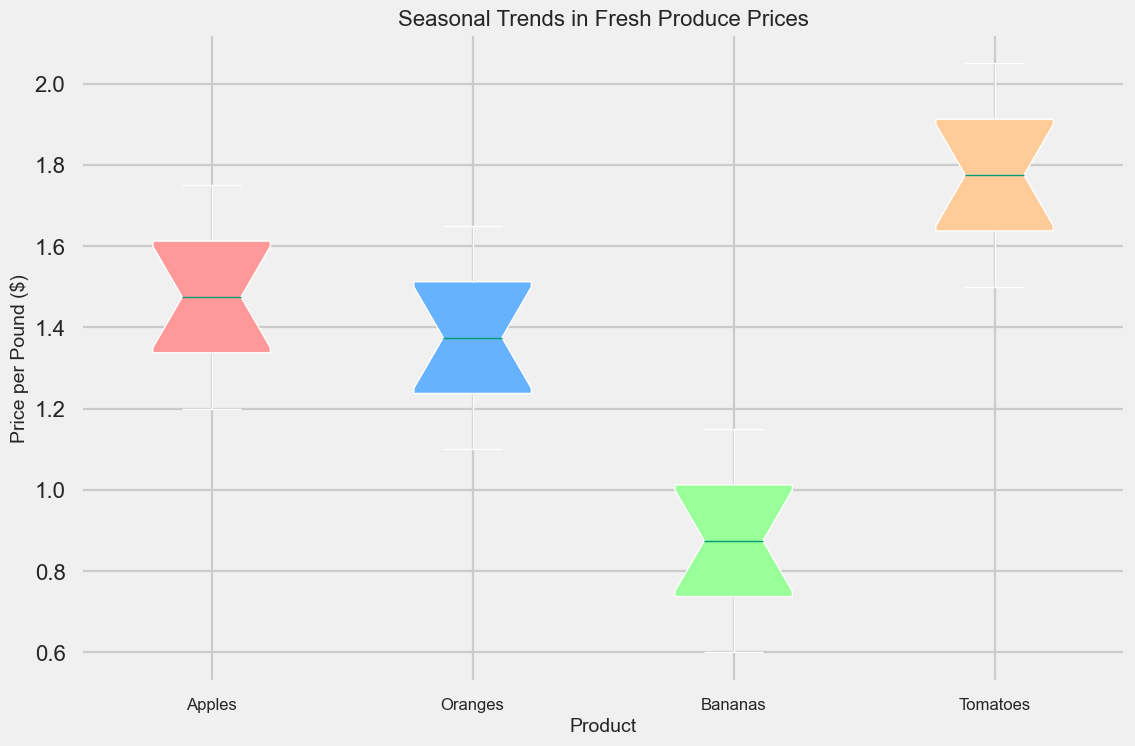What is the median price of Apples? To find the median price of Apples, look at the middle value of the box plot for Apples. The median is represented by the line inside the box.
Answer: 1.475 What product has the highest median price? Compare the medians of all the box plots. The product with the highest median is the one with the highest line inside its respective box.
Answer: Tomatoes Which product shows the least variation in price? The product with the least variation in price will have the shortest box and whiskers.
Answer: Bananas What is the range of prices for Oranges? The range is calculated by finding the difference between the maximum and minimum prices. These are represented by the whiskers' endpoints. For Oranges, subtract the minimum whisker value from the maximum whisker value.
Answer: 0.55 Are the median prices of any two products equal? Compare the lines inside the boxes of each product. If any two lines are at the same height, their medians are equal.
Answer: No Which product's price has the widest interquartile range (IQR)? The IQR is the length of the box in the box plot. The product with the widest box has the largest IQR.
Answer: Tomatoes Does any product's price consistently increase over the months? Check each product's box and whiskers from left to right (January to December). If any product shows a steady rising pattern, its price consistently increases.
Answer: Yes, Tomatoes What is the maximum price for Apples? The maximum price for Apples is the top end of the whisker above the box for Apples.
Answer: 1.75 Which product's price fluctuates the most? The product with the longest box and whiskers indicates the most fluctuation.
Answer: Tomatoes How do the prices of Bananas in June compare to those of Oranges in the same month? Look at the box plots for both Bananas and Oranges in June. Compare the median lines or ranges.
Answer: Bananas are significantly cheaper than Oranges in June 